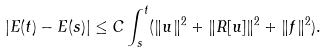Convert formula to latex. <formula><loc_0><loc_0><loc_500><loc_500>| E ( t ) - E ( s ) | \leq C \int _ { s } ^ { t } ( \| u \| ^ { 2 } + \| R [ u ] \| ^ { 2 } + \| f \| ^ { 2 } ) .</formula> 